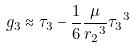<formula> <loc_0><loc_0><loc_500><loc_500>g _ { 3 } \approx \tau _ { 3 } - \frac { 1 } { 6 } \frac { \mu } { { r _ { 2 } } ^ { 3 } } { \tau _ { 3 } } ^ { 3 }</formula> 